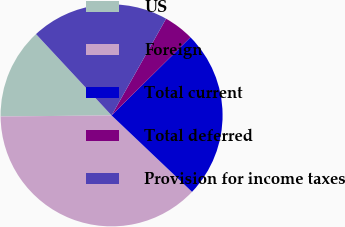Convert chart. <chart><loc_0><loc_0><loc_500><loc_500><pie_chart><fcel>US<fcel>Foreign<fcel>Total current<fcel>Total deferred<fcel>Provision for income taxes<nl><fcel>13.24%<fcel>37.75%<fcel>24.51%<fcel>4.41%<fcel>20.09%<nl></chart> 